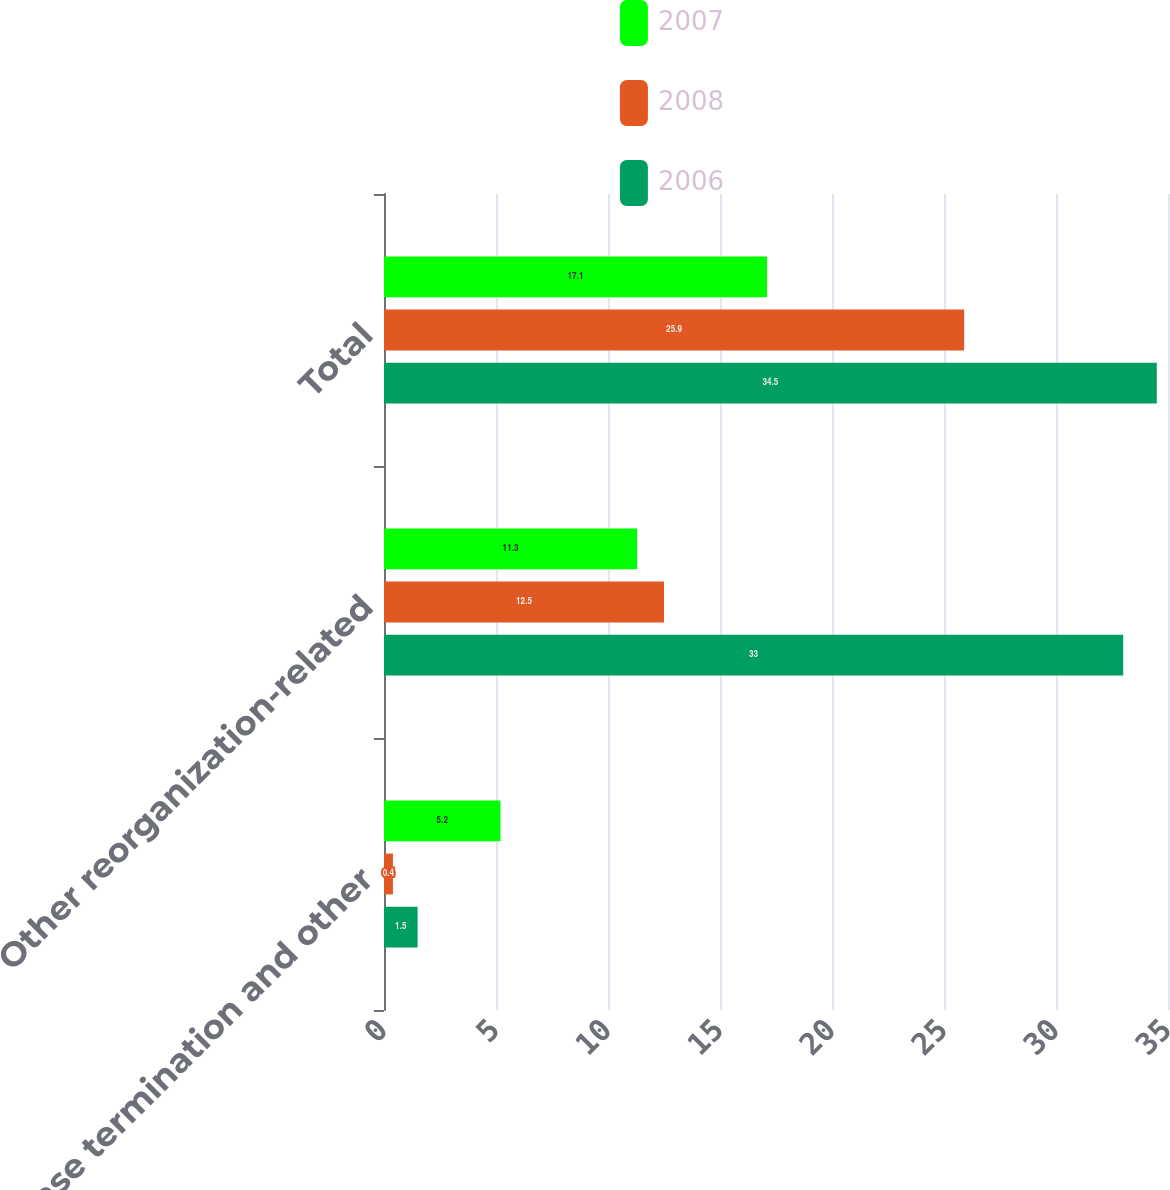<chart> <loc_0><loc_0><loc_500><loc_500><stacked_bar_chart><ecel><fcel>Lease termination and other<fcel>Other reorganization-related<fcel>Total<nl><fcel>2007<fcel>5.2<fcel>11.3<fcel>17.1<nl><fcel>2008<fcel>0.4<fcel>12.5<fcel>25.9<nl><fcel>2006<fcel>1.5<fcel>33<fcel>34.5<nl></chart> 